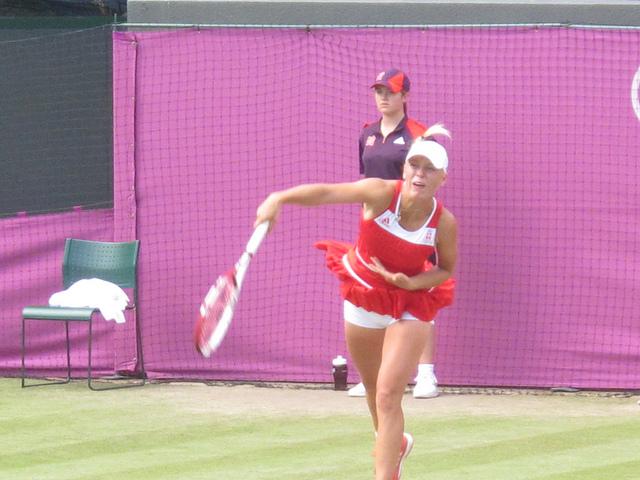How is her hair being kept back?
Quick response, please. Ponytail. Which hand is the woman holding the racket in?
Be succinct. Right. Is she wearing a bathing suit?
Quick response, please. No. 